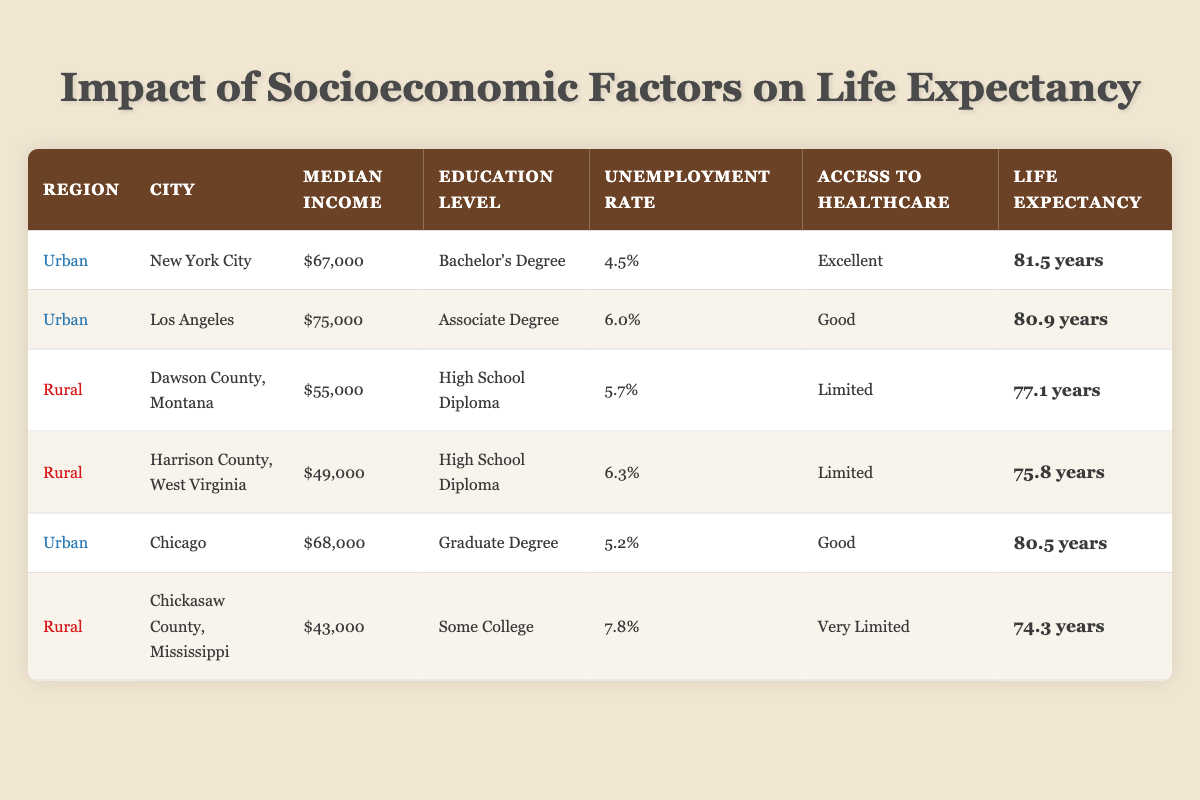What is the life expectancy in New York City? From the table, we can see that for the city of New York City, the life expectancy listed is 81.5 years.
Answer: 81.5 years Which region has a higher average life expectancy, urban or rural? To find the average life expectancy for the urban region, we take the average of New York City (81.5), Los Angeles (80.9), and Chicago (80.5). The average is (81.5 + 80.9 + 80.5) / 3 = 80.9667 years. For the rural region, we average Dawson County (77.1), Harrison County (75.8), and Chickasaw County (74.3). The average is (77.1 + 75.8 + 74.3) / 3 = 75.7333 years. Urban has the higher average at approximately 80.97 years.
Answer: Urban Is the unemployment rate in Chicago lower than that in Harrison County? From the table, the unemployment rate for Chicago is 5.2%, and for Harrison County, it is 6.3%. Since 5.2% is less than 6.3%, the statement is true.
Answer: Yes What is the median income difference between Los Angeles and Chickasaw County? The median income in Los Angeles is $75,000, while in Chickasaw County it is $43,000. The difference can be calculated as $75,000 - $43,000 = $32,000.
Answer: $32,000 How does access to healthcare compare between urban and rural areas? Urban cities generally report their access to healthcare as either 'Excellent' or 'Good', while rural areas, including Dawson County, Harrison County, and Chickasaw County, have 'Limited' or 'Very Limited' access. This indicates that urban areas have significantly better access to healthcare.
Answer: Urban areas have better access to healthcare 